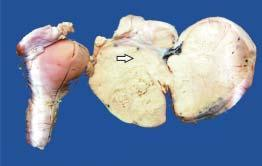how much side does specimen of the uterus, cervix and adnexa show?
Answer the question using a single word or phrase. One 